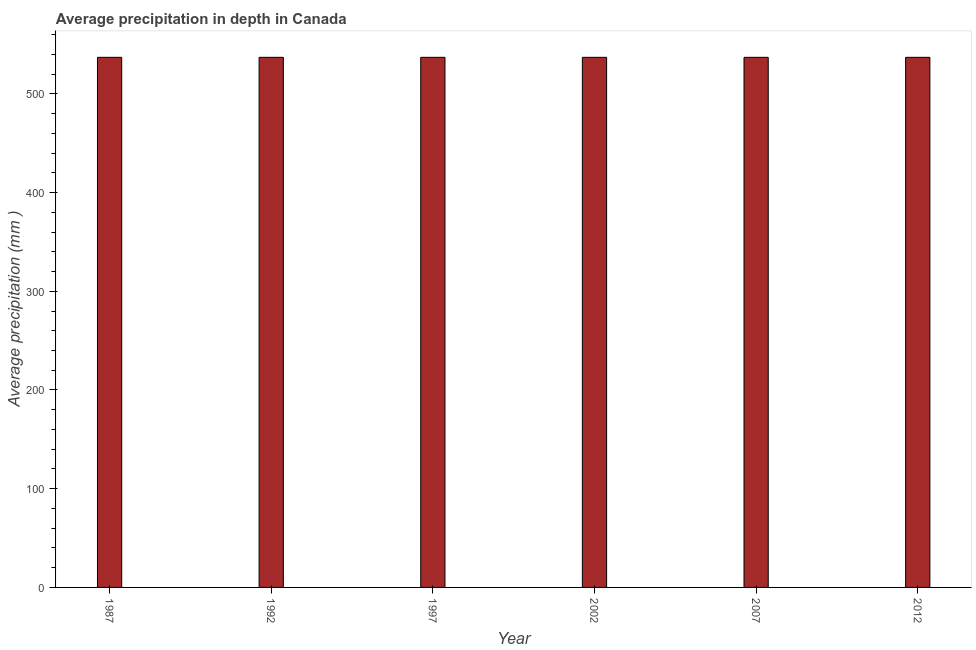What is the title of the graph?
Your response must be concise. Average precipitation in depth in Canada. What is the label or title of the X-axis?
Your answer should be very brief. Year. What is the label or title of the Y-axis?
Keep it short and to the point. Average precipitation (mm ). What is the average precipitation in depth in 1997?
Your answer should be compact. 537. Across all years, what is the maximum average precipitation in depth?
Give a very brief answer. 537. Across all years, what is the minimum average precipitation in depth?
Your answer should be very brief. 537. In which year was the average precipitation in depth maximum?
Offer a terse response. 1987. What is the sum of the average precipitation in depth?
Your response must be concise. 3222. What is the average average precipitation in depth per year?
Provide a succinct answer. 537. What is the median average precipitation in depth?
Offer a very short reply. 537. In how many years, is the average precipitation in depth greater than 540 mm?
Your answer should be very brief. 0. Do a majority of the years between 2002 and 1997 (inclusive) have average precipitation in depth greater than 460 mm?
Make the answer very short. No. Is the difference between the average precipitation in depth in 1997 and 2007 greater than the difference between any two years?
Give a very brief answer. Yes. What is the difference between the highest and the lowest average precipitation in depth?
Keep it short and to the point. 0. Are all the bars in the graph horizontal?
Make the answer very short. No. What is the difference between two consecutive major ticks on the Y-axis?
Provide a succinct answer. 100. What is the Average precipitation (mm ) in 1987?
Offer a terse response. 537. What is the Average precipitation (mm ) in 1992?
Keep it short and to the point. 537. What is the Average precipitation (mm ) in 1997?
Keep it short and to the point. 537. What is the Average precipitation (mm ) of 2002?
Your response must be concise. 537. What is the Average precipitation (mm ) of 2007?
Ensure brevity in your answer.  537. What is the Average precipitation (mm ) of 2012?
Your response must be concise. 537. What is the difference between the Average precipitation (mm ) in 1987 and 2002?
Your answer should be compact. 0. What is the difference between the Average precipitation (mm ) in 1987 and 2012?
Provide a short and direct response. 0. What is the difference between the Average precipitation (mm ) in 1992 and 1997?
Offer a very short reply. 0. What is the difference between the Average precipitation (mm ) in 1992 and 2002?
Your response must be concise. 0. What is the difference between the Average precipitation (mm ) in 1992 and 2012?
Ensure brevity in your answer.  0. What is the difference between the Average precipitation (mm ) in 1997 and 2002?
Provide a short and direct response. 0. What is the difference between the Average precipitation (mm ) in 1997 and 2012?
Give a very brief answer. 0. What is the difference between the Average precipitation (mm ) in 2002 and 2007?
Make the answer very short. 0. What is the difference between the Average precipitation (mm ) in 2002 and 2012?
Offer a very short reply. 0. What is the difference between the Average precipitation (mm ) in 2007 and 2012?
Offer a terse response. 0. What is the ratio of the Average precipitation (mm ) in 1987 to that in 1997?
Your answer should be very brief. 1. What is the ratio of the Average precipitation (mm ) in 1992 to that in 1997?
Offer a very short reply. 1. What is the ratio of the Average precipitation (mm ) in 1992 to that in 2002?
Provide a succinct answer. 1. What is the ratio of the Average precipitation (mm ) in 1992 to that in 2012?
Your answer should be compact. 1. What is the ratio of the Average precipitation (mm ) in 1997 to that in 2007?
Offer a terse response. 1. What is the ratio of the Average precipitation (mm ) in 2002 to that in 2007?
Your response must be concise. 1. What is the ratio of the Average precipitation (mm ) in 2002 to that in 2012?
Make the answer very short. 1. 